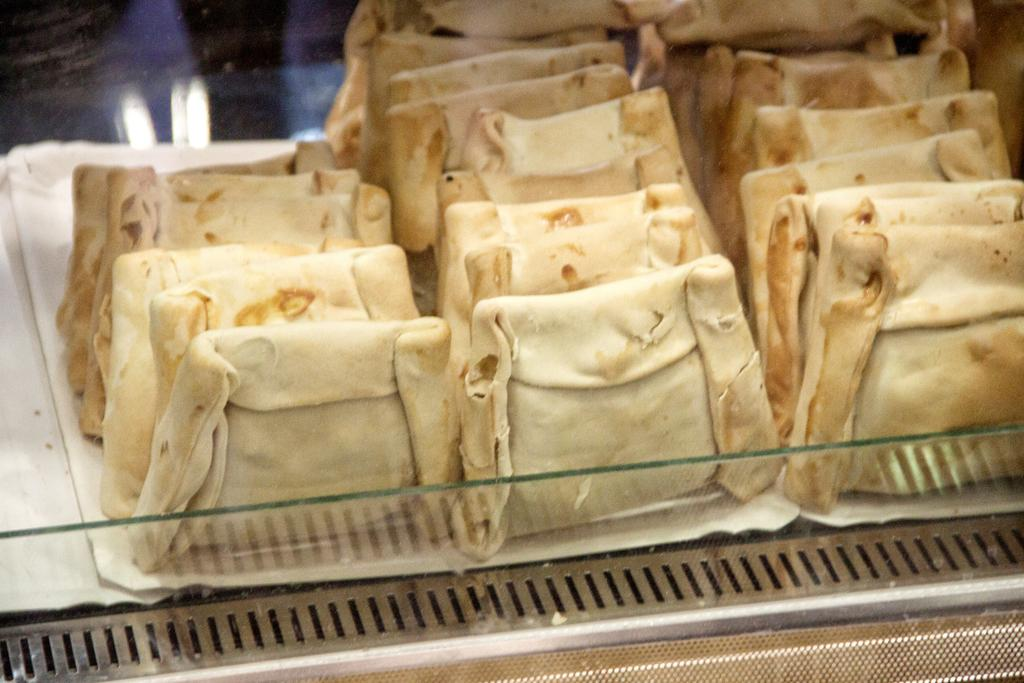What is the main subject of the image? The main subject of the image is food. Where is the food located in the image? The food is in the center of the image. What other object can be seen in the image? There is a glass in the image. How is the glass positioned in the image? The glass is in the front of the image. What type of prose is being recited by the frog in the image? There is no frog present in the image, and therefore no prose being recited. 